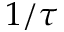Convert formula to latex. <formula><loc_0><loc_0><loc_500><loc_500>1 / \tau</formula> 